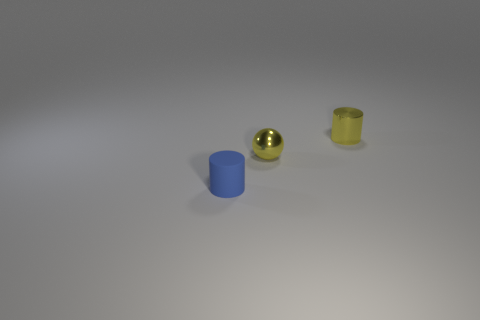Add 1 blue metal cylinders. How many objects exist? 4 Subtract all cylinders. How many objects are left? 1 Subtract 1 yellow cylinders. How many objects are left? 2 Subtract all shiny cylinders. Subtract all small metallic objects. How many objects are left? 0 Add 2 blue rubber cylinders. How many blue rubber cylinders are left? 3 Add 1 blue things. How many blue things exist? 2 